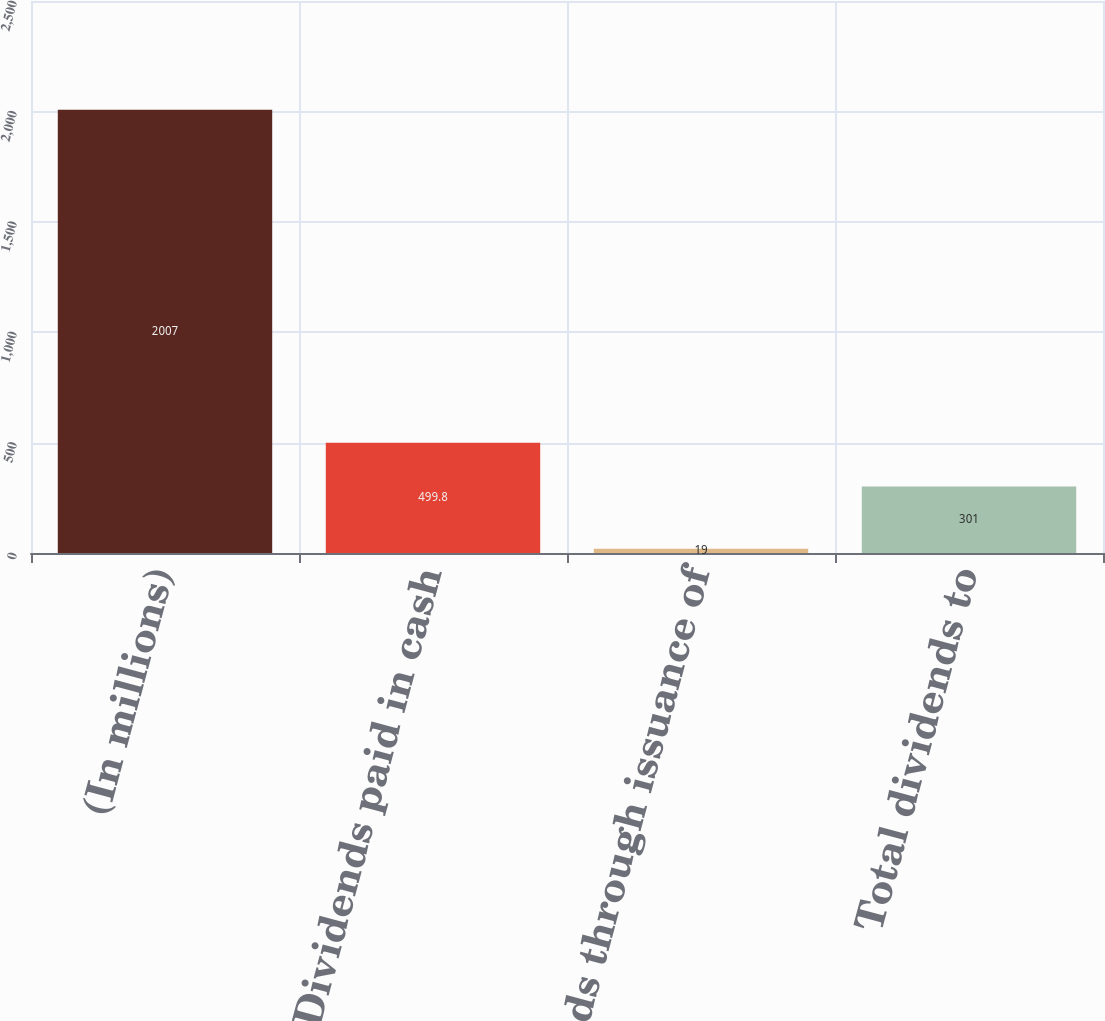<chart> <loc_0><loc_0><loc_500><loc_500><bar_chart><fcel>(In millions)<fcel>Dividends paid in cash<fcel>Dividends through issuance of<fcel>Total dividends to<nl><fcel>2007<fcel>499.8<fcel>19<fcel>301<nl></chart> 